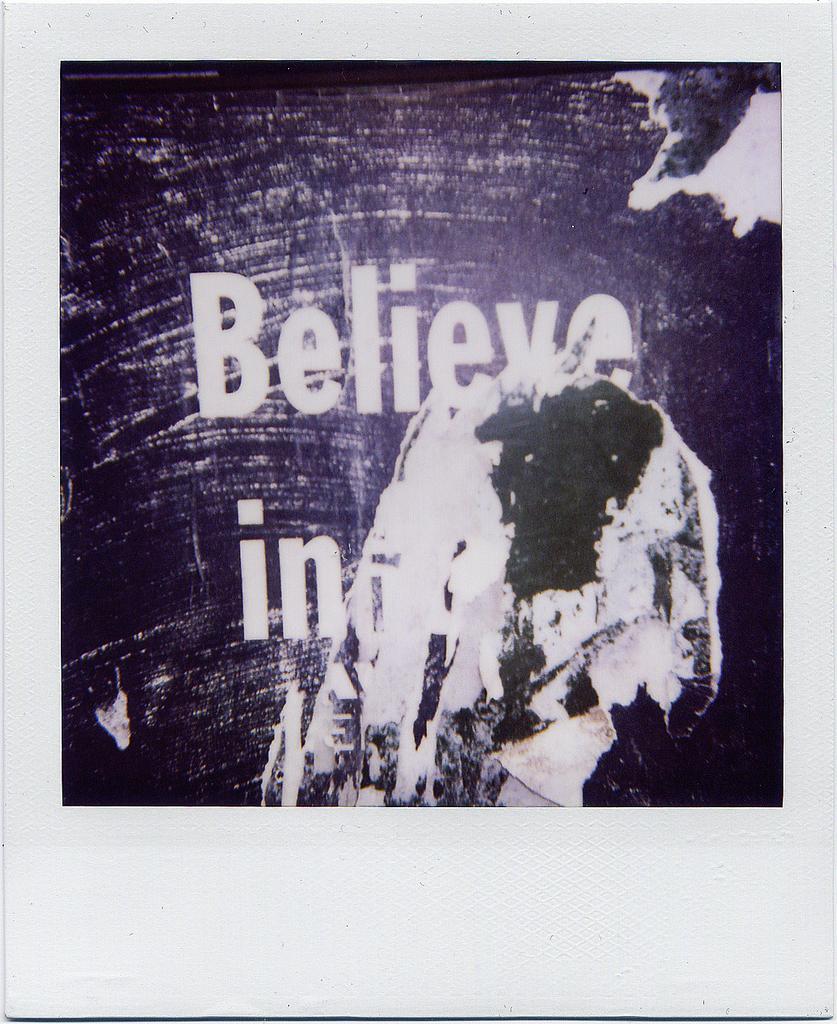Could you give a brief overview of what you see in this image? In this image we can see a poster on a white surface. On the poster something is written. 